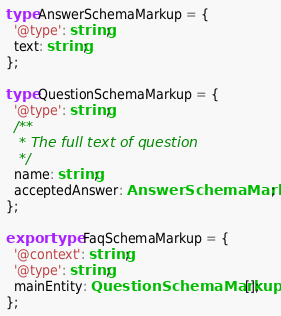Convert code to text. <code><loc_0><loc_0><loc_500><loc_500><_TypeScript_>type AnswerSchemaMarkup = {
  '@type': string;
  text: string;
};

type QuestionSchemaMarkup = {
  '@type': string;
  /**
   * The full text of question
   */
  name: string;
  acceptedAnswer: AnswerSchemaMarkup;
};

export type FaqSchemaMarkup = {
  '@context': string;
  '@type': string;
  mainEntity: QuestionSchemaMarkup[];
};
</code> 